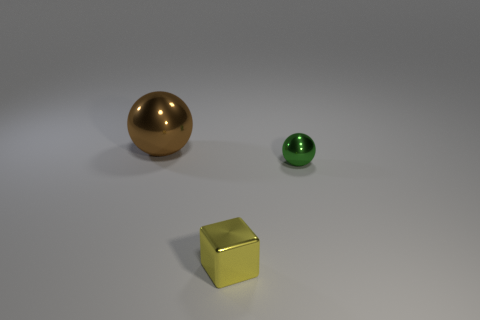What number of things are either large cyan metallic objects or objects in front of the green object?
Your response must be concise. 1. What is the yellow block made of?
Offer a very short reply. Metal. Is there any other thing that is the same color as the metallic cube?
Your response must be concise. No. Is the large brown object the same shape as the yellow thing?
Make the answer very short. No. How big is the sphere that is on the left side of the small thing in front of the sphere that is in front of the brown thing?
Your response must be concise. Large. There is a sphere left of the yellow cube; what is its color?
Provide a short and direct response. Brown. Are there any other brown metallic things of the same shape as the big thing?
Keep it short and to the point. No. There is a green object that is the same size as the yellow block; what shape is it?
Your answer should be compact. Sphere. How many tiny things are left of the small green metallic sphere and behind the cube?
Offer a terse response. 0. Is the number of metal blocks that are left of the brown metal ball less than the number of yellow shiny objects?
Ensure brevity in your answer.  Yes. 